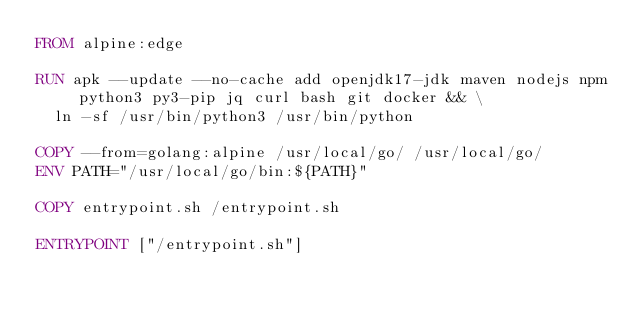Convert code to text. <code><loc_0><loc_0><loc_500><loc_500><_Dockerfile_>FROM alpine:edge

RUN apk --update --no-cache add openjdk17-jdk maven nodejs npm python3 py3-pip jq curl bash git docker && \
	ln -sf /usr/bin/python3 /usr/bin/python

COPY --from=golang:alpine /usr/local/go/ /usr/local/go/
ENV PATH="/usr/local/go/bin:${PATH}"

COPY entrypoint.sh /entrypoint.sh

ENTRYPOINT ["/entrypoint.sh"]
</code> 